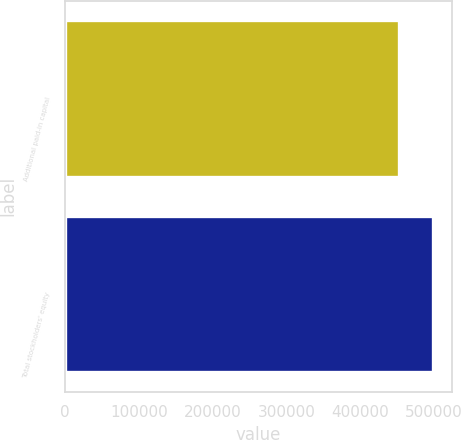Convert chart. <chart><loc_0><loc_0><loc_500><loc_500><bar_chart><fcel>Additional paid-in capital<fcel>Total stockholders' equity<nl><fcel>453013<fcel>499003<nl></chart> 